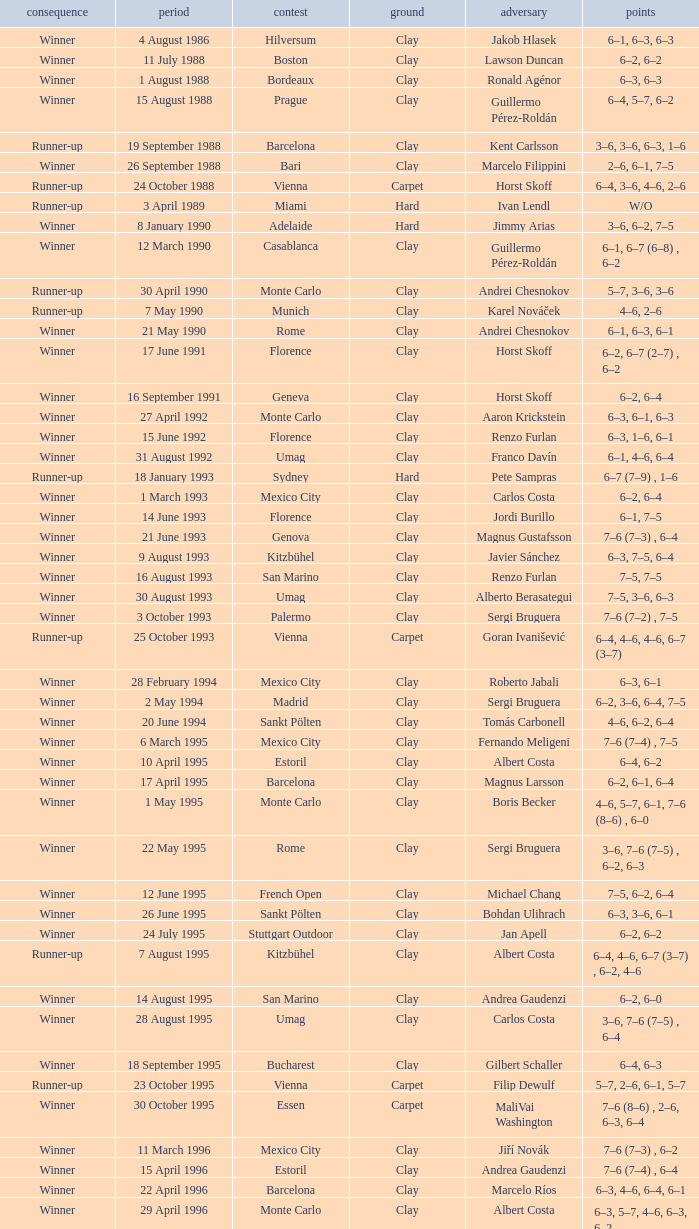What is the score when the championship is rome and the opponent is richard krajicek? 6–2, 6–4, 3–6, 6–3. 